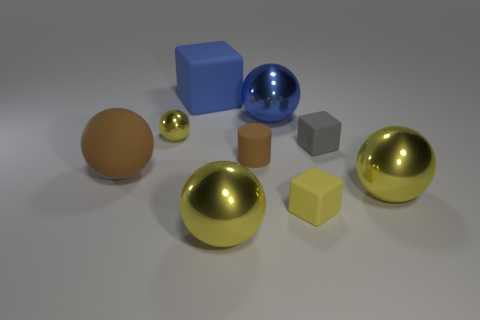There is a tiny rubber object that is behind the cylinder; is its shape the same as the blue thing in front of the blue rubber cube?
Offer a very short reply. No. Are there the same number of big blue shiny objects that are in front of the tiny yellow ball and blue things that are to the left of the brown matte sphere?
Your answer should be very brief. Yes. What is the shape of the yellow thing behind the tiny rubber thing that is left of the small yellow thing in front of the brown rubber sphere?
Give a very brief answer. Sphere. Does the block that is behind the blue ball have the same material as the tiny sphere that is to the left of the small gray matte block?
Your response must be concise. No. What is the shape of the large yellow object on the right side of the large blue metal sphere?
Ensure brevity in your answer.  Sphere. Is the number of large shiny cubes less than the number of blue rubber objects?
Your answer should be very brief. Yes. There is a object behind the metallic ball behind the small yellow metallic object; are there any big rubber balls that are behind it?
Your answer should be compact. No. How many metallic objects are either tiny blue cylinders or brown balls?
Make the answer very short. 0. Is the tiny shiny object the same color as the tiny cylinder?
Ensure brevity in your answer.  No. There is a large cube; what number of blue things are to the right of it?
Give a very brief answer. 1. 